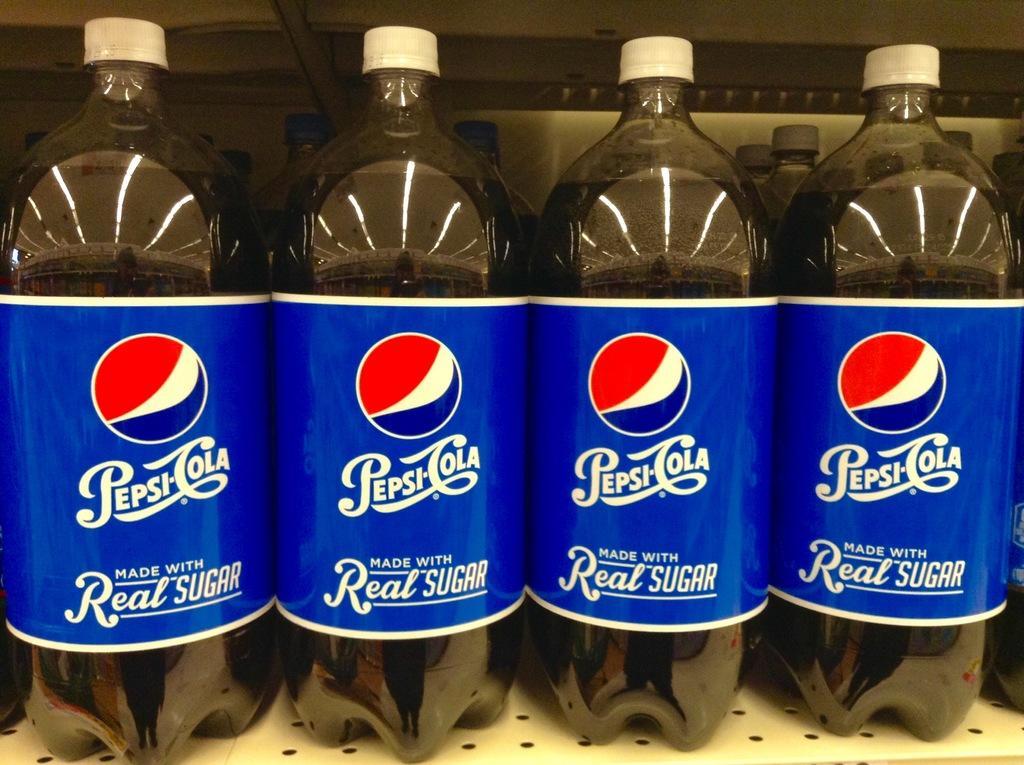Can you describe this image briefly? Here we can see some bottles with the drink. This is poster. And this is rack. 